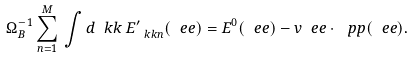Convert formula to latex. <formula><loc_0><loc_0><loc_500><loc_500>\Omega _ { B } ^ { - 1 } \sum _ { n = 1 } ^ { M } \, \int d \ k k \, E ^ { \prime } _ { \ k k n } ( \ e e ) = E ^ { 0 } ( \ e e ) - v \ e e \cdot \ p p ( \ e e ) .</formula> 